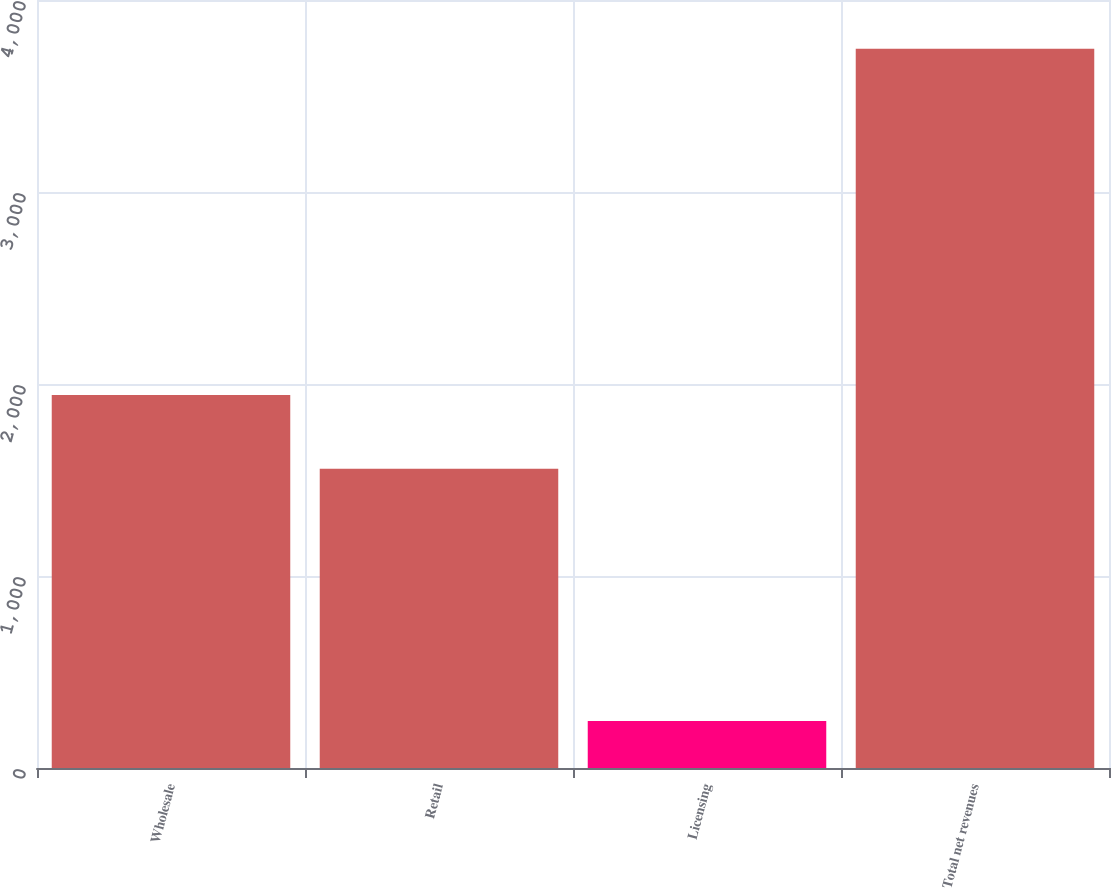Convert chart to OTSL. <chart><loc_0><loc_0><loc_500><loc_500><bar_chart><fcel>Wholesale<fcel>Retail<fcel>Licensing<fcel>Total net revenues<nl><fcel>1942.5<fcel>1558.6<fcel>245.2<fcel>3746.3<nl></chart> 